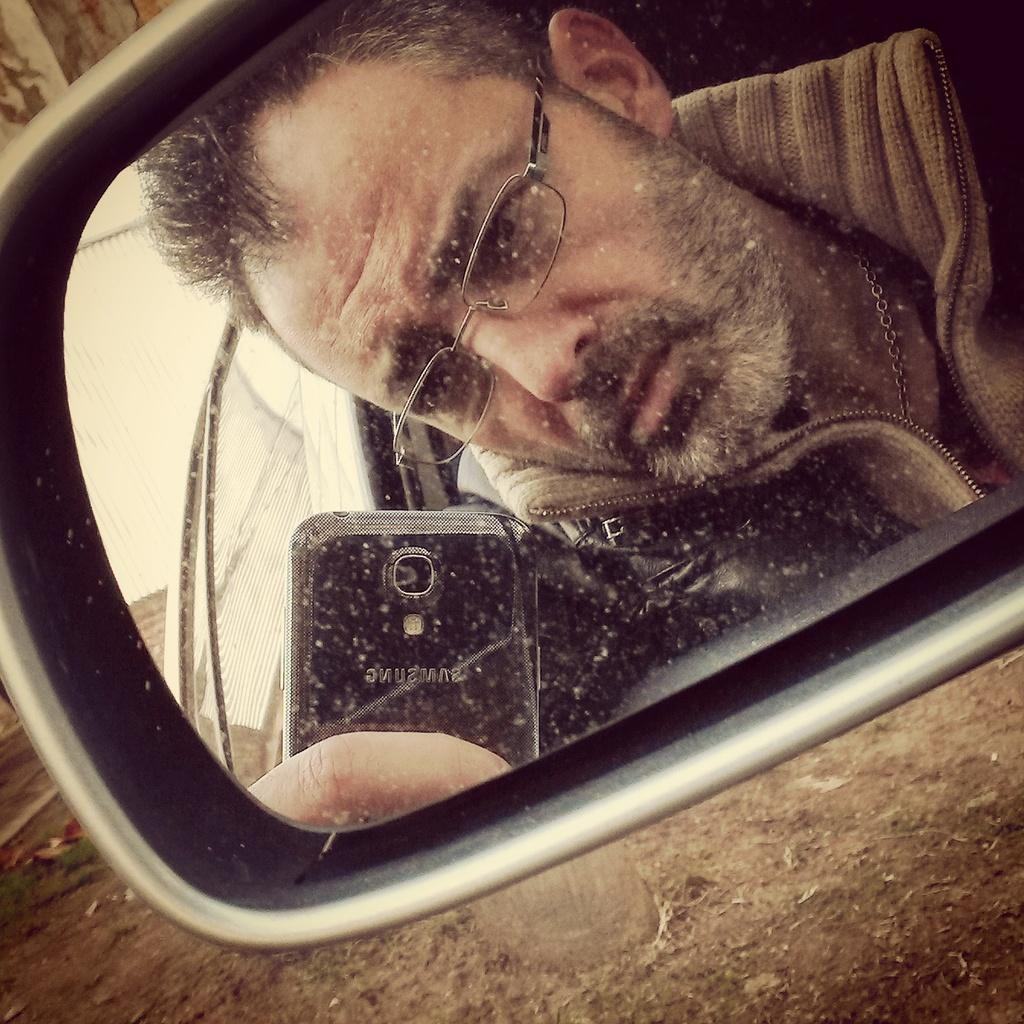What object is present in the image that allows for a reflection? There is a side mirror in the image. What can be seen in the reflection of the side mirror? A person holding a mobile is visible in the side mirror. What type of surface is at the bottom of the image? There is soil at the bottom of the image. What type of can is visible in the image? There is no can present in the image. What kind of wall can be seen in the image? There is no wall present in the image. How old is the son in the image? There is no son present in the image. 